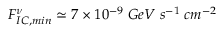<formula> <loc_0><loc_0><loc_500><loc_500>F _ { I C , \min } ^ { \nu } \simeq 7 \times 1 0 ^ { - 9 } \, G e V \, s ^ { - 1 } \, c m ^ { - 2 }</formula> 